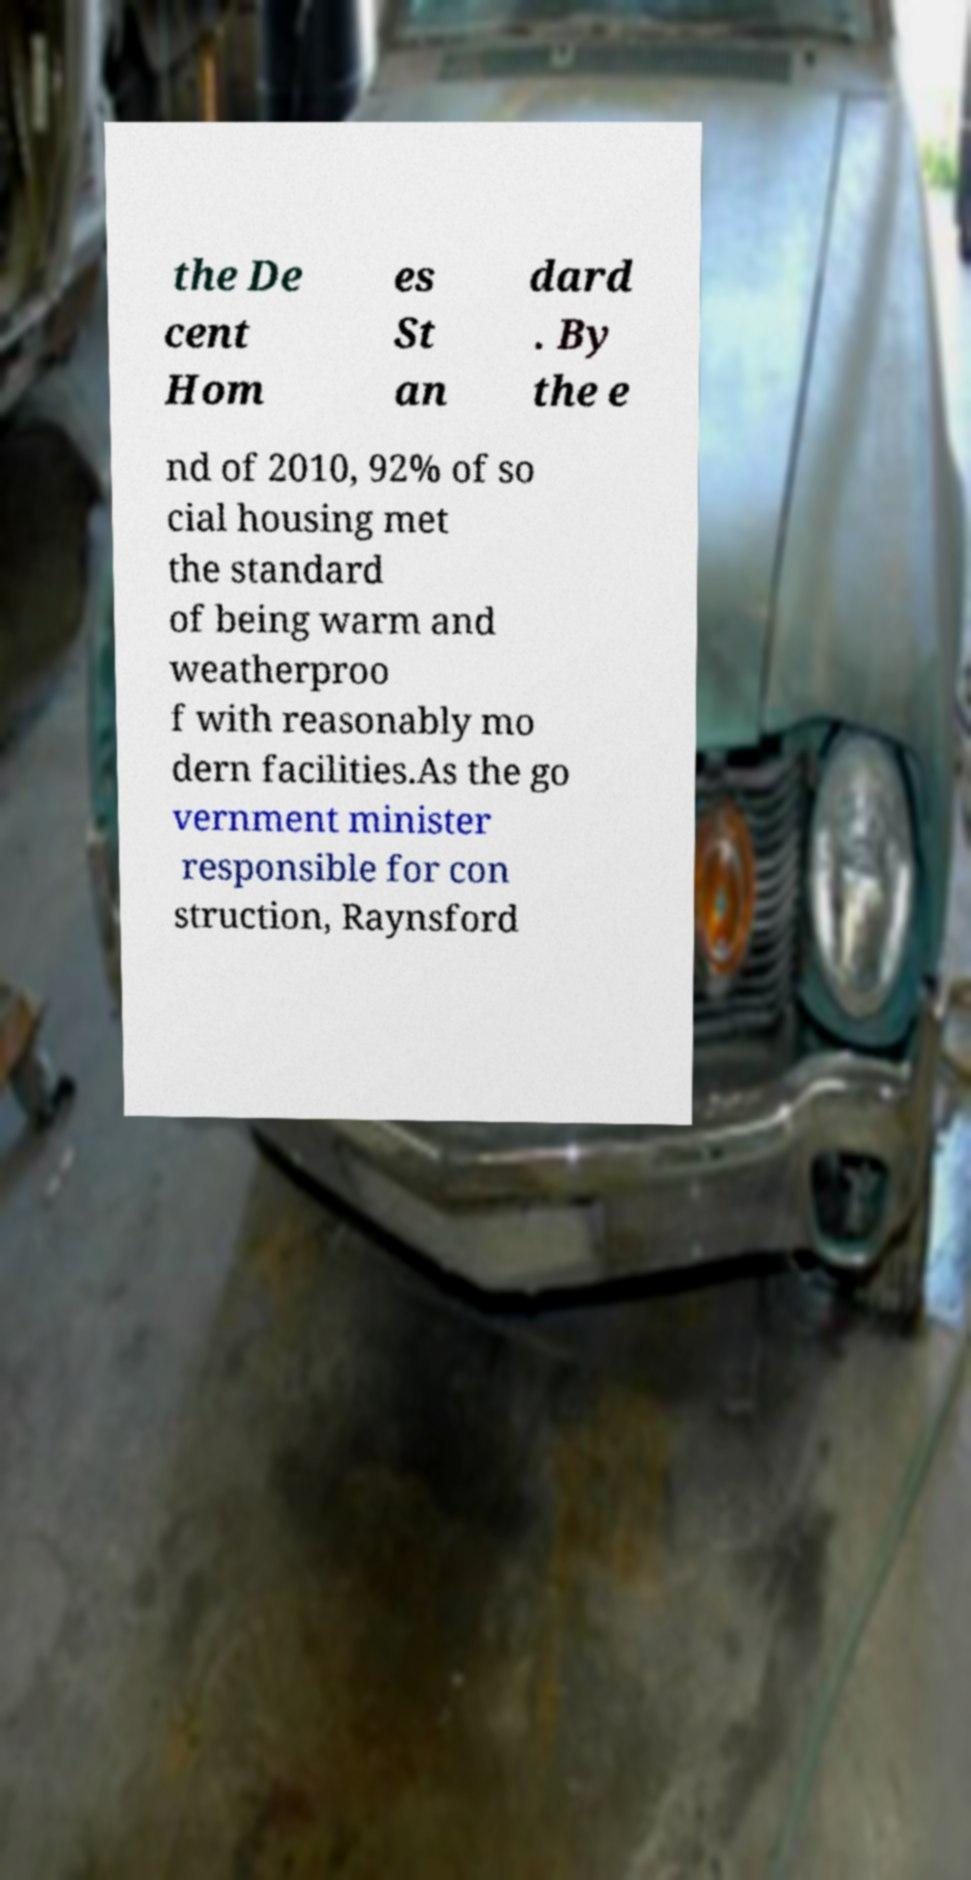Please read and relay the text visible in this image. What does it say? the De cent Hom es St an dard . By the e nd of 2010, 92% of so cial housing met the standard of being warm and weatherproo f with reasonably mo dern facilities.As the go vernment minister responsible for con struction, Raynsford 